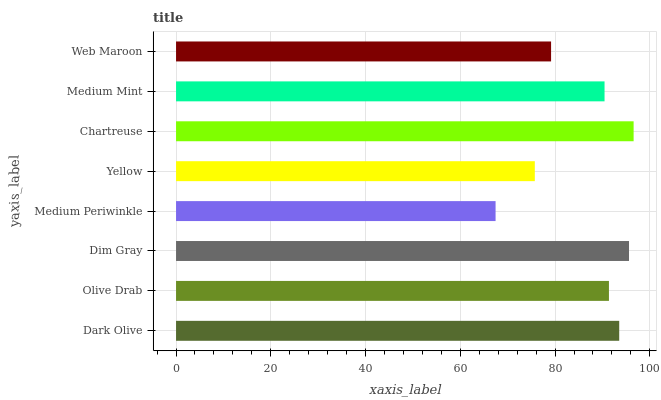Is Medium Periwinkle the minimum?
Answer yes or no. Yes. Is Chartreuse the maximum?
Answer yes or no. Yes. Is Olive Drab the minimum?
Answer yes or no. No. Is Olive Drab the maximum?
Answer yes or no. No. Is Dark Olive greater than Olive Drab?
Answer yes or no. Yes. Is Olive Drab less than Dark Olive?
Answer yes or no. Yes. Is Olive Drab greater than Dark Olive?
Answer yes or no. No. Is Dark Olive less than Olive Drab?
Answer yes or no. No. Is Olive Drab the high median?
Answer yes or no. Yes. Is Medium Mint the low median?
Answer yes or no. Yes. Is Chartreuse the high median?
Answer yes or no. No. Is Dark Olive the low median?
Answer yes or no. No. 